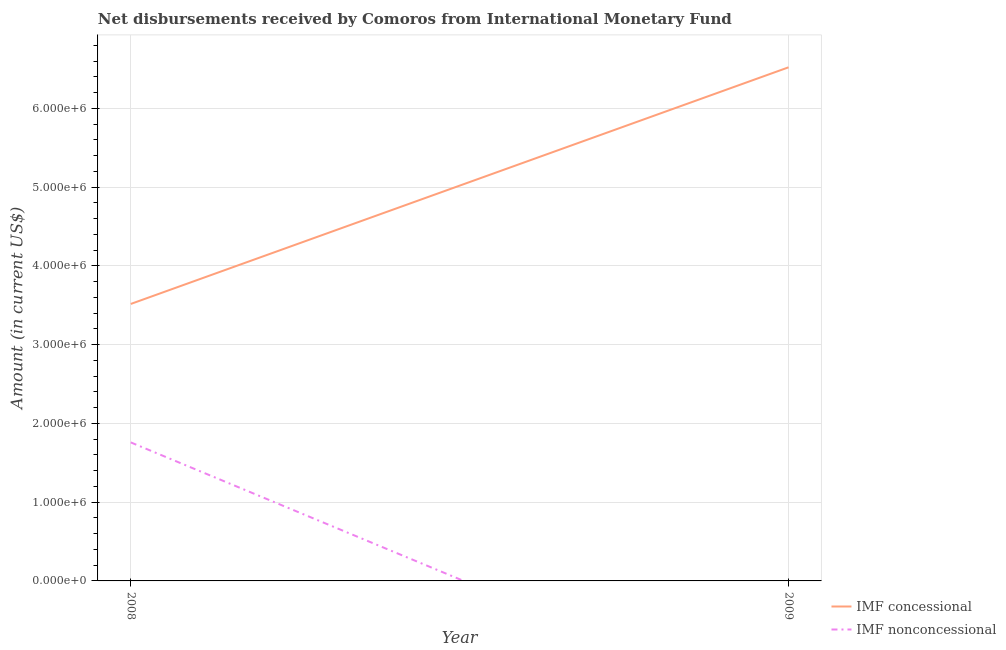What is the net concessional disbursements from imf in 2009?
Provide a short and direct response. 6.52e+06. Across all years, what is the maximum net concessional disbursements from imf?
Your answer should be compact. 6.52e+06. Across all years, what is the minimum net non concessional disbursements from imf?
Ensure brevity in your answer.  0. What is the total net non concessional disbursements from imf in the graph?
Keep it short and to the point. 1.76e+06. What is the difference between the net concessional disbursements from imf in 2008 and that in 2009?
Your answer should be very brief. -3.00e+06. What is the difference between the net non concessional disbursements from imf in 2009 and the net concessional disbursements from imf in 2008?
Provide a short and direct response. -3.52e+06. What is the average net non concessional disbursements from imf per year?
Give a very brief answer. 8.80e+05. In the year 2008, what is the difference between the net concessional disbursements from imf and net non concessional disbursements from imf?
Ensure brevity in your answer.  1.76e+06. What is the ratio of the net concessional disbursements from imf in 2008 to that in 2009?
Give a very brief answer. 0.54. Is the net concessional disbursements from imf in 2008 less than that in 2009?
Ensure brevity in your answer.  Yes. In how many years, is the net non concessional disbursements from imf greater than the average net non concessional disbursements from imf taken over all years?
Your answer should be very brief. 1. Is the net non concessional disbursements from imf strictly greater than the net concessional disbursements from imf over the years?
Give a very brief answer. No. How many years are there in the graph?
Your response must be concise. 2. Are the values on the major ticks of Y-axis written in scientific E-notation?
Provide a short and direct response. Yes. How many legend labels are there?
Ensure brevity in your answer.  2. What is the title of the graph?
Provide a short and direct response. Net disbursements received by Comoros from International Monetary Fund. What is the label or title of the X-axis?
Your answer should be very brief. Year. What is the label or title of the Y-axis?
Provide a short and direct response. Amount (in current US$). What is the Amount (in current US$) in IMF concessional in 2008?
Your answer should be very brief. 3.52e+06. What is the Amount (in current US$) of IMF nonconcessional in 2008?
Your answer should be very brief. 1.76e+06. What is the Amount (in current US$) in IMF concessional in 2009?
Provide a succinct answer. 6.52e+06. Across all years, what is the maximum Amount (in current US$) of IMF concessional?
Your answer should be very brief. 6.52e+06. Across all years, what is the maximum Amount (in current US$) of IMF nonconcessional?
Offer a very short reply. 1.76e+06. Across all years, what is the minimum Amount (in current US$) in IMF concessional?
Provide a short and direct response. 3.52e+06. Across all years, what is the minimum Amount (in current US$) in IMF nonconcessional?
Make the answer very short. 0. What is the total Amount (in current US$) of IMF concessional in the graph?
Offer a terse response. 1.00e+07. What is the total Amount (in current US$) of IMF nonconcessional in the graph?
Provide a succinct answer. 1.76e+06. What is the difference between the Amount (in current US$) in IMF concessional in 2008 and that in 2009?
Ensure brevity in your answer.  -3.00e+06. What is the average Amount (in current US$) in IMF concessional per year?
Offer a terse response. 5.02e+06. What is the average Amount (in current US$) of IMF nonconcessional per year?
Keep it short and to the point. 8.80e+05. In the year 2008, what is the difference between the Amount (in current US$) in IMF concessional and Amount (in current US$) in IMF nonconcessional?
Provide a succinct answer. 1.76e+06. What is the ratio of the Amount (in current US$) of IMF concessional in 2008 to that in 2009?
Provide a short and direct response. 0.54. What is the difference between the highest and the second highest Amount (in current US$) in IMF concessional?
Make the answer very short. 3.00e+06. What is the difference between the highest and the lowest Amount (in current US$) of IMF concessional?
Your answer should be very brief. 3.00e+06. What is the difference between the highest and the lowest Amount (in current US$) of IMF nonconcessional?
Give a very brief answer. 1.76e+06. 